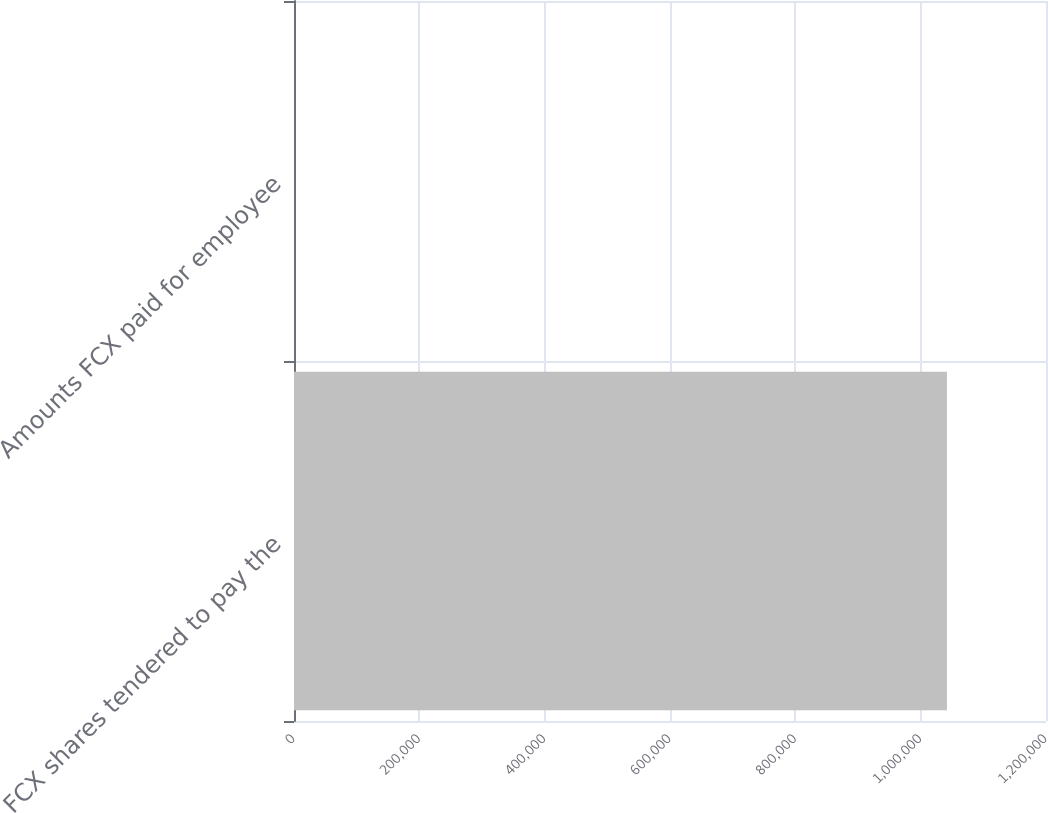Convert chart. <chart><loc_0><loc_0><loc_500><loc_500><bar_chart><fcel>FCX shares tendered to pay the<fcel>Amounts FCX paid for employee<nl><fcel>1.04194e+06<fcel>15<nl></chart> 